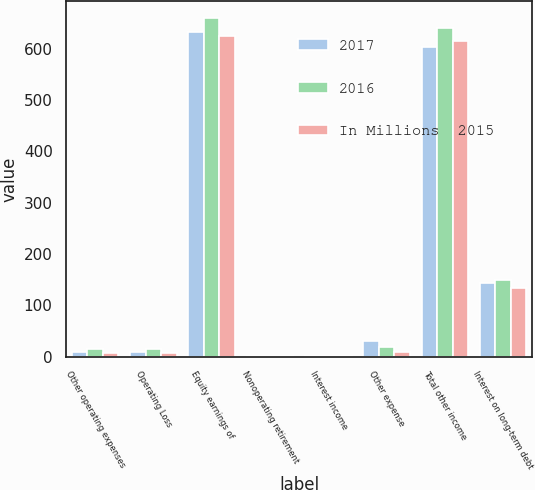<chart> <loc_0><loc_0><loc_500><loc_500><stacked_bar_chart><ecel><fcel>Other operating expenses<fcel>Operating Loss<fcel>Equity earnings of<fcel>Nonoperating retirement<fcel>Interest income<fcel>Other expense<fcel>Total other income<fcel>Interest on long-term debt<nl><fcel>2017<fcel>9<fcel>9<fcel>633<fcel>1<fcel>1<fcel>31<fcel>604<fcel>143<nl><fcel>2016<fcel>14<fcel>14<fcel>660<fcel>1<fcel>1<fcel>19<fcel>641<fcel>150<nl><fcel>In Millions  2015<fcel>8<fcel>8<fcel>625<fcel>1<fcel>1<fcel>9<fcel>616<fcel>134<nl></chart> 